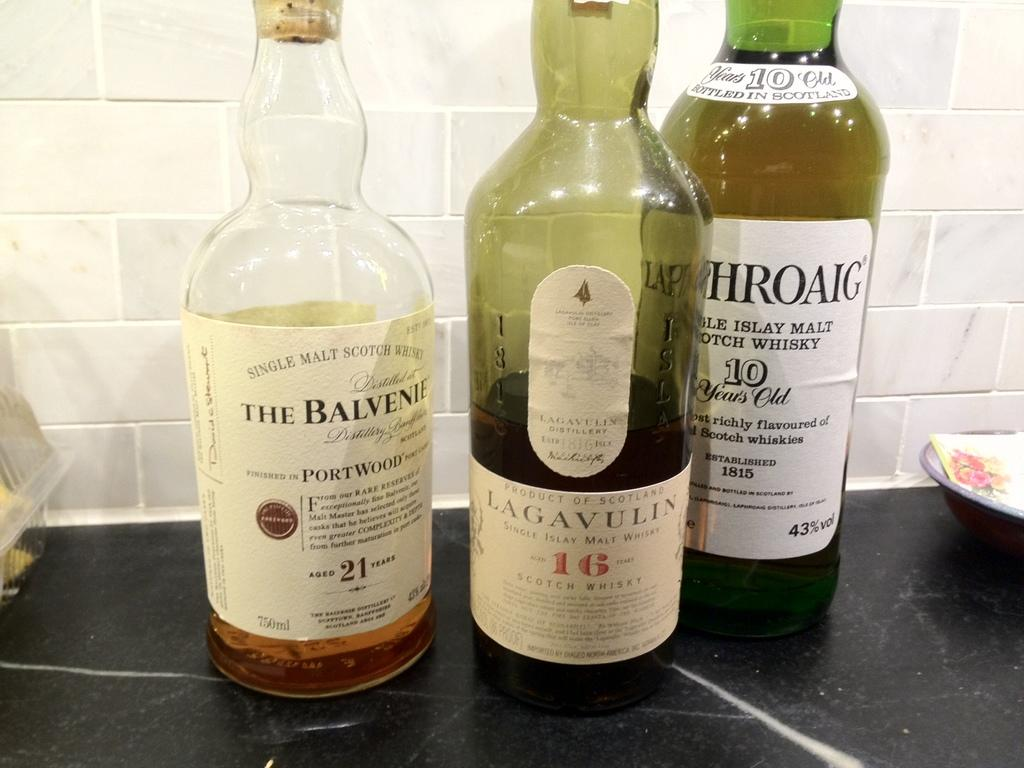<image>
Share a concise interpretation of the image provided. The Balvenie whiskey is next to two other bottles. 